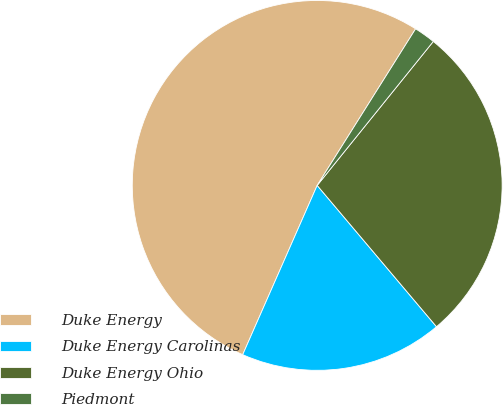<chart> <loc_0><loc_0><loc_500><loc_500><pie_chart><fcel>Duke Energy<fcel>Duke Energy Carolinas<fcel>Duke Energy Ohio<fcel>Piedmont<nl><fcel>52.34%<fcel>17.76%<fcel>28.04%<fcel>1.87%<nl></chart> 